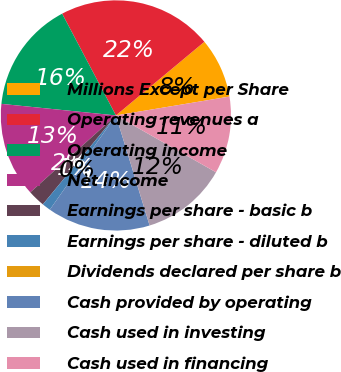Convert chart to OTSL. <chart><loc_0><loc_0><loc_500><loc_500><pie_chart><fcel>Millions Except per Share<fcel>Operating revenues a<fcel>Operating income<fcel>Net income<fcel>Earnings per share - basic b<fcel>Earnings per share - diluted b<fcel>Dividends declared per share b<fcel>Cash provided by operating<fcel>Cash used in investing<fcel>Cash used in financing<nl><fcel>8.43%<fcel>21.69%<fcel>15.66%<fcel>13.25%<fcel>2.41%<fcel>1.21%<fcel>0.0%<fcel>14.46%<fcel>12.05%<fcel>10.84%<nl></chart> 